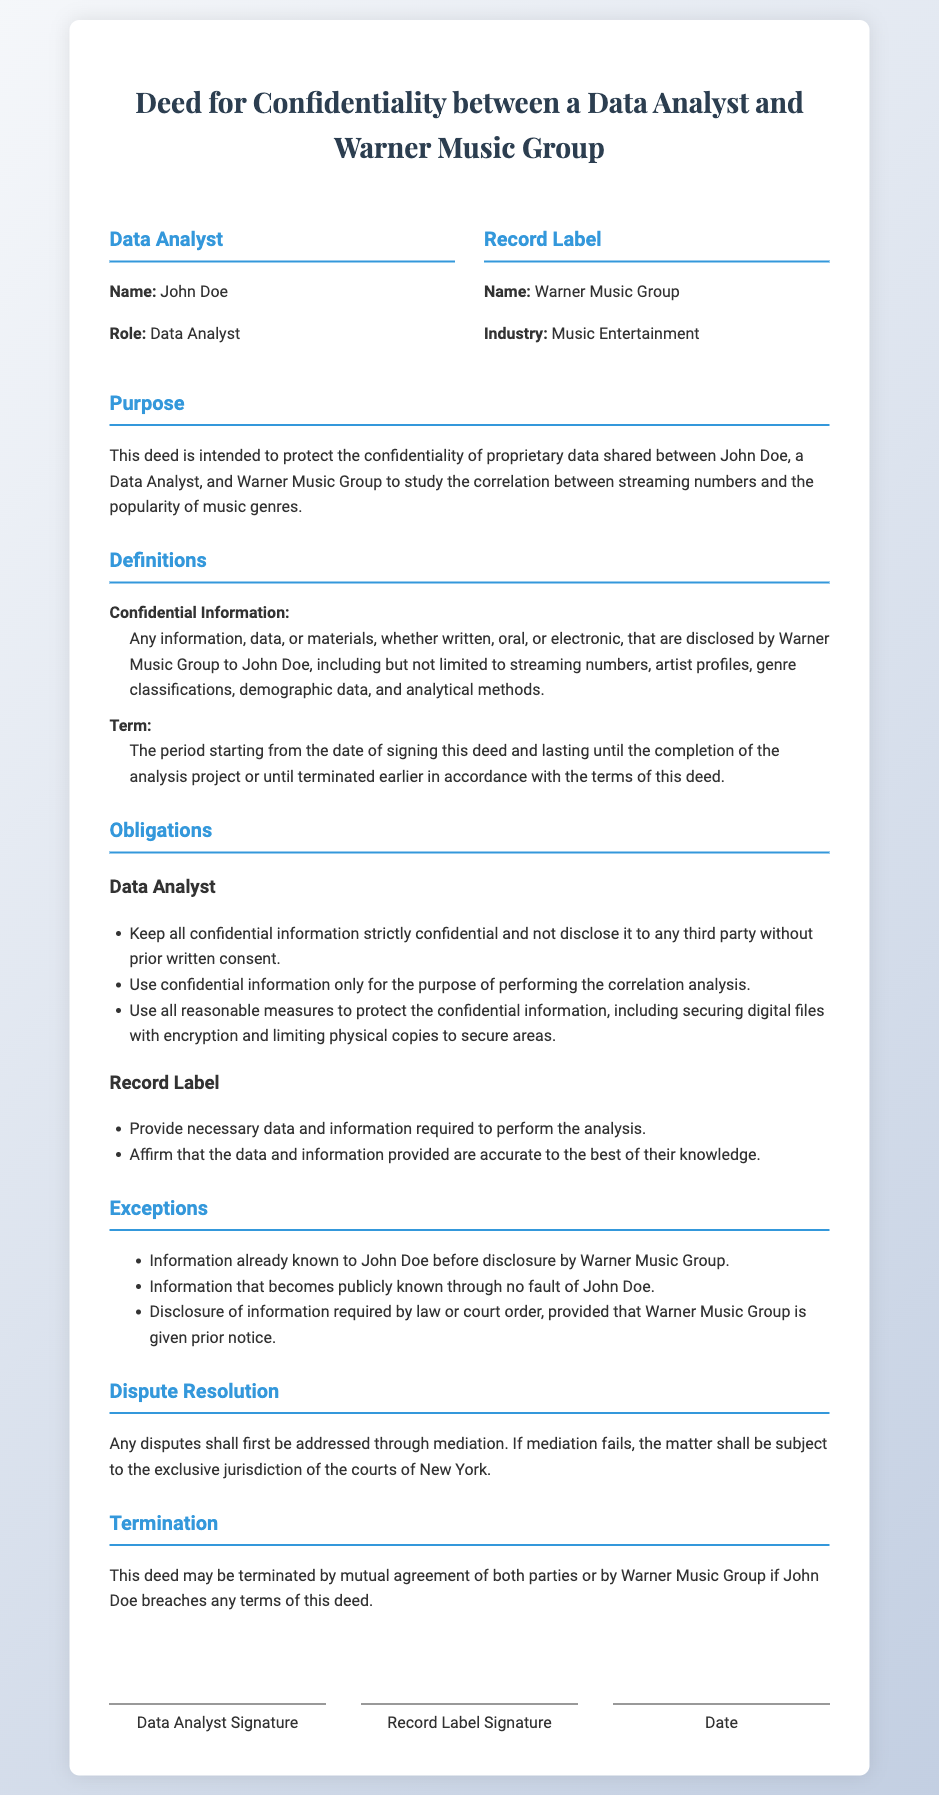What is the name of the Data Analyst? The document explicitly states the Data Analyst's name, which is John Doe.
Answer: John Doe What is the name of the Record Label? The document specifies the Record Label's name, which is Warner Music Group.
Answer: Warner Music Group What is the purpose of the deed? The purpose is outlined clearly in the document, stating it is to protect the confidentiality of proprietary data shared for the correlation analysis.
Answer: Protect the confidentiality of proprietary data What is considered confidential information? The document defines confidential information as any data disclosed by Warner Music Group, including streaming numbers and demographic data.
Answer: Streaming numbers, artist profiles, genre classifications, demographic data, analytical methods What must the Data Analyst do with the confidential information? The deed outlines that the Data Analyst must keep the information confidential and use it solely for the analysis purpose.
Answer: Keep it confidential and use it for analysis What is the duration of the deed? The Term of the deed is specified to start from the signing date until the analysis project is completed or terminated.
Answer: Until completion of the analysis project What happens if there is a dispute? The document states that disputes should first be addressed through mediation.
Answer: Mediation What can terminate the deed? The deed specifies that it can be terminated by mutual agreement or if the Data Analyst breaches any terms.
Answer: Mutual agreement or breach of terms What must the Record Label provide? According to the obligations, the Record Label is required to provide necessary data and information for the analysis.
Answer: Necessary data and information 